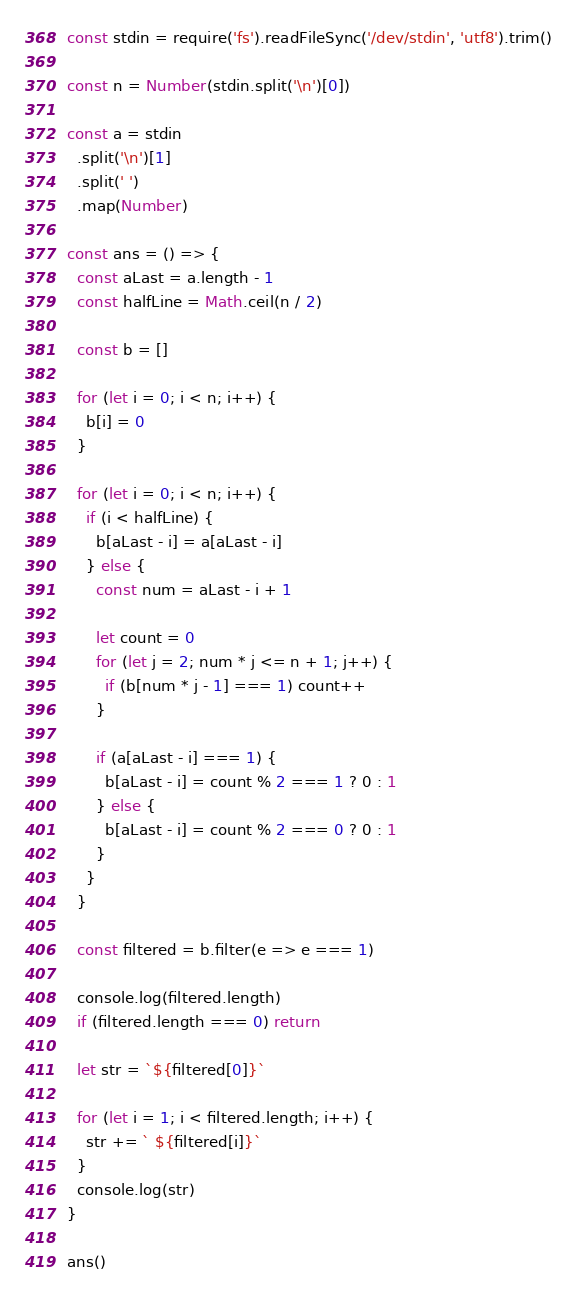Convert code to text. <code><loc_0><loc_0><loc_500><loc_500><_TypeScript_>const stdin = require('fs').readFileSync('/dev/stdin', 'utf8').trim()

const n = Number(stdin.split('\n')[0])

const a = stdin
  .split('\n')[1]
  .split(' ')
  .map(Number)

const ans = () => {
  const aLast = a.length - 1
  const halfLine = Math.ceil(n / 2)

  const b = []

  for (let i = 0; i < n; i++) {
    b[i] = 0
  }

  for (let i = 0; i < n; i++) {
    if (i < halfLine) {
      b[aLast - i] = a[aLast - i]
    } else {
      const num = aLast - i + 1

      let count = 0
      for (let j = 2; num * j <= n + 1; j++) {
        if (b[num * j - 1] === 1) count++
      }

      if (a[aLast - i] === 1) {
        b[aLast - i] = count % 2 === 1 ? 0 : 1
      } else {
        b[aLast - i] = count % 2 === 0 ? 0 : 1
      }
    }
  }

  const filtered = b.filter(e => e === 1)

  console.log(filtered.length)
  if (filtered.length === 0) return

  let str = `${filtered[0]}`

  for (let i = 1; i < filtered.length; i++) {
    str += ` ${filtered[i]}`
  }
  console.log(str)
}

ans()
</code> 